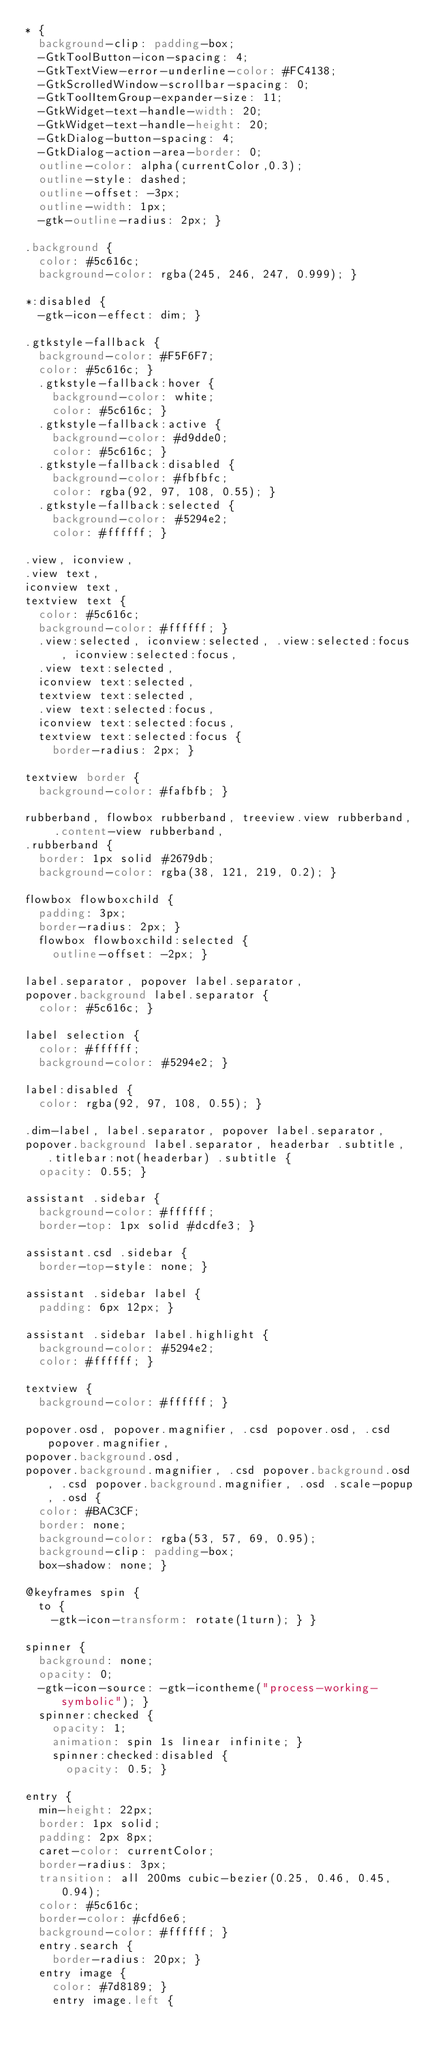Convert code to text. <code><loc_0><loc_0><loc_500><loc_500><_CSS_>* {
  background-clip: padding-box;
  -GtkToolButton-icon-spacing: 4;
  -GtkTextView-error-underline-color: #FC4138;
  -GtkScrolledWindow-scrollbar-spacing: 0;
  -GtkToolItemGroup-expander-size: 11;
  -GtkWidget-text-handle-width: 20;
  -GtkWidget-text-handle-height: 20;
  -GtkDialog-button-spacing: 4;
  -GtkDialog-action-area-border: 0;
  outline-color: alpha(currentColor,0.3);
  outline-style: dashed;
  outline-offset: -3px;
  outline-width: 1px;
  -gtk-outline-radius: 2px; }

.background {
  color: #5c616c;
  background-color: rgba(245, 246, 247, 0.999); }

*:disabled {
  -gtk-icon-effect: dim; }

.gtkstyle-fallback {
  background-color: #F5F6F7;
  color: #5c616c; }
  .gtkstyle-fallback:hover {
    background-color: white;
    color: #5c616c; }
  .gtkstyle-fallback:active {
    background-color: #d9dde0;
    color: #5c616c; }
  .gtkstyle-fallback:disabled {
    background-color: #fbfbfc;
    color: rgba(92, 97, 108, 0.55); }
  .gtkstyle-fallback:selected {
    background-color: #5294e2;
    color: #ffffff; }

.view, iconview,
.view text,
iconview text,
textview text {
  color: #5c616c;
  background-color: #ffffff; }
  .view:selected, iconview:selected, .view:selected:focus, iconview:selected:focus,
  .view text:selected,
  iconview text:selected,
  textview text:selected,
  .view text:selected:focus,
  iconview text:selected:focus,
  textview text:selected:focus {
    border-radius: 2px; }

textview border {
  background-color: #fafbfb; }

rubberband, flowbox rubberband, treeview.view rubberband, .content-view rubberband,
.rubberband {
  border: 1px solid #2679db;
  background-color: rgba(38, 121, 219, 0.2); }

flowbox flowboxchild {
  padding: 3px;
  border-radius: 2px; }
  flowbox flowboxchild:selected {
    outline-offset: -2px; }

label.separator, popover label.separator,
popover.background label.separator {
  color: #5c616c; }

label selection {
  color: #ffffff;
  background-color: #5294e2; }

label:disabled {
  color: rgba(92, 97, 108, 0.55); }

.dim-label, label.separator, popover label.separator,
popover.background label.separator, headerbar .subtitle, .titlebar:not(headerbar) .subtitle {
  opacity: 0.55; }

assistant .sidebar {
  background-color: #ffffff;
  border-top: 1px solid #dcdfe3; }

assistant.csd .sidebar {
  border-top-style: none; }

assistant .sidebar label {
  padding: 6px 12px; }

assistant .sidebar label.highlight {
  background-color: #5294e2;
  color: #ffffff; }

textview {
  background-color: #ffffff; }

popover.osd, popover.magnifier, .csd popover.osd, .csd popover.magnifier,
popover.background.osd,
popover.background.magnifier, .csd popover.background.osd, .csd popover.background.magnifier, .osd .scale-popup, .osd {
  color: #BAC3CF;
  border: none;
  background-color: rgba(53, 57, 69, 0.95);
  background-clip: padding-box;
  box-shadow: none; }

@keyframes spin {
  to {
    -gtk-icon-transform: rotate(1turn); } }

spinner {
  background: none;
  opacity: 0;
  -gtk-icon-source: -gtk-icontheme("process-working-symbolic"); }
  spinner:checked {
    opacity: 1;
    animation: spin 1s linear infinite; }
    spinner:checked:disabled {
      opacity: 0.5; }

entry {
  min-height: 22px;
  border: 1px solid;
  padding: 2px 8px;
  caret-color: currentColor;
  border-radius: 3px;
  transition: all 200ms cubic-bezier(0.25, 0.46, 0.45, 0.94);
  color: #5c616c;
  border-color: #cfd6e6;
  background-color: #ffffff; }
  entry.search {
    border-radius: 20px; }
  entry image {
    color: #7d8189; }
    entry image.left {</code> 